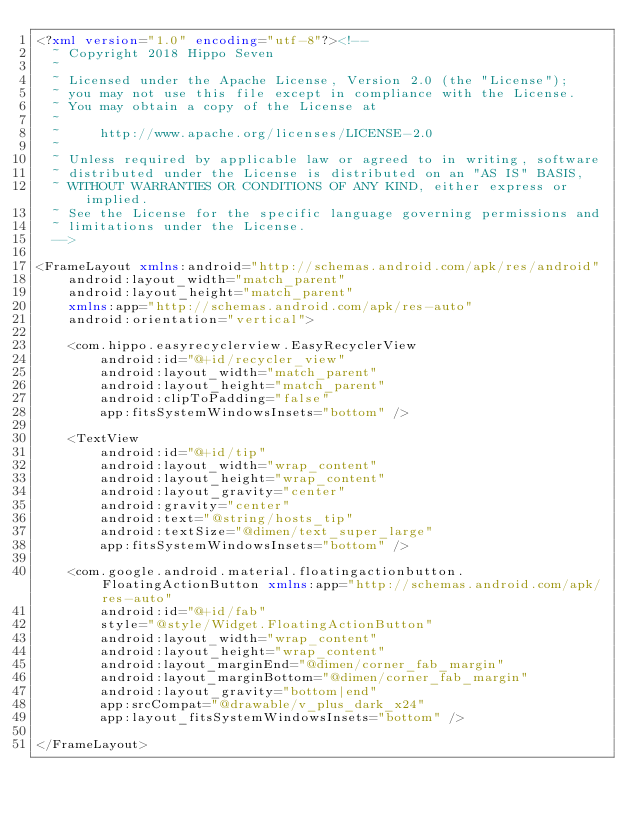Convert code to text. <code><loc_0><loc_0><loc_500><loc_500><_XML_><?xml version="1.0" encoding="utf-8"?><!--
  ~ Copyright 2018 Hippo Seven
  ~
  ~ Licensed under the Apache License, Version 2.0 (the "License");
  ~ you may not use this file except in compliance with the License.
  ~ You may obtain a copy of the License at
  ~
  ~     http://www.apache.org/licenses/LICENSE-2.0
  ~
  ~ Unless required by applicable law or agreed to in writing, software
  ~ distributed under the License is distributed on an "AS IS" BASIS,
  ~ WITHOUT WARRANTIES OR CONDITIONS OF ANY KIND, either express or implied.
  ~ See the License for the specific language governing permissions and
  ~ limitations under the License.
  -->

<FrameLayout xmlns:android="http://schemas.android.com/apk/res/android"
    android:layout_width="match_parent"
    android:layout_height="match_parent"
    xmlns:app="http://schemas.android.com/apk/res-auto"
    android:orientation="vertical">

    <com.hippo.easyrecyclerview.EasyRecyclerView
        android:id="@+id/recycler_view"
        android:layout_width="match_parent"
        android:layout_height="match_parent"
        android:clipToPadding="false"
        app:fitsSystemWindowsInsets="bottom" />

    <TextView
        android:id="@+id/tip"
        android:layout_width="wrap_content"
        android:layout_height="wrap_content"
        android:layout_gravity="center"
        android:gravity="center"
        android:text="@string/hosts_tip"
        android:textSize="@dimen/text_super_large"
        app:fitsSystemWindowsInsets="bottom" />

    <com.google.android.material.floatingactionbutton.FloatingActionButton xmlns:app="http://schemas.android.com/apk/res-auto"
        android:id="@+id/fab"
        style="@style/Widget.FloatingActionButton"
        android:layout_width="wrap_content"
        android:layout_height="wrap_content"
        android:layout_marginEnd="@dimen/corner_fab_margin"
        android:layout_marginBottom="@dimen/corner_fab_margin"
        android:layout_gravity="bottom|end"
        app:srcCompat="@drawable/v_plus_dark_x24"
        app:layout_fitsSystemWindowsInsets="bottom" />

</FrameLayout>
</code> 